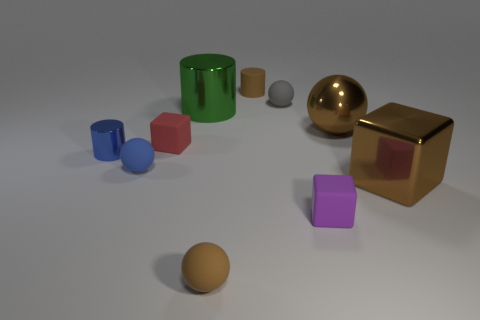Subtract all shiny cylinders. How many cylinders are left? 1 Subtract 3 spheres. How many spheres are left? 1 Add 6 big shiny spheres. How many big shiny spheres exist? 7 Subtract all blue cylinders. How many cylinders are left? 2 Subtract 0 gray cubes. How many objects are left? 10 Subtract all cylinders. How many objects are left? 7 Subtract all red cylinders. Subtract all purple spheres. How many cylinders are left? 3 Subtract all cyan balls. How many brown cylinders are left? 1 Subtract all gray metallic blocks. Subtract all metal balls. How many objects are left? 9 Add 9 blue metallic cylinders. How many blue metallic cylinders are left? 10 